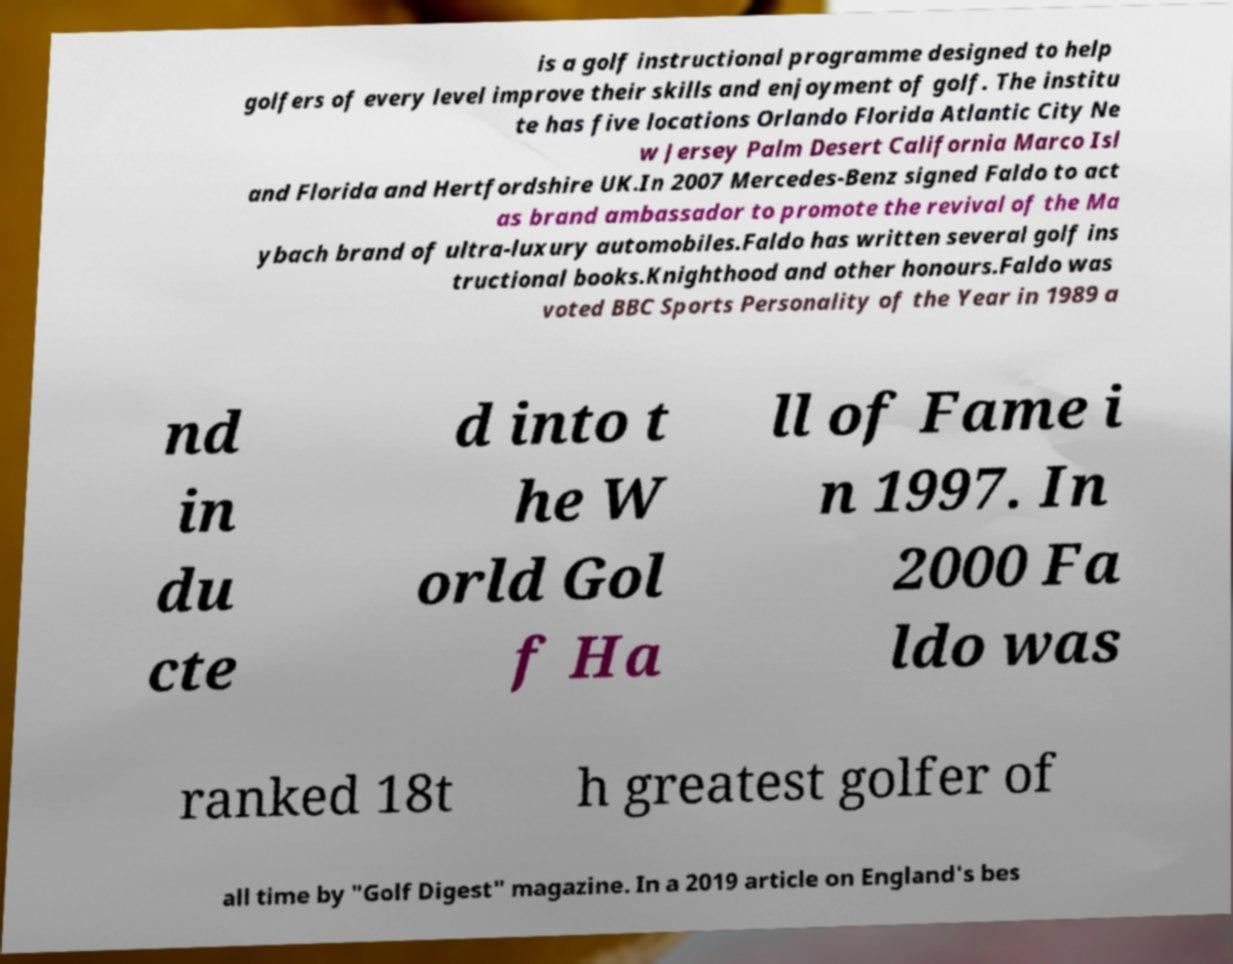Can you accurately transcribe the text from the provided image for me? is a golf instructional programme designed to help golfers of every level improve their skills and enjoyment of golf. The institu te has five locations Orlando Florida Atlantic City Ne w Jersey Palm Desert California Marco Isl and Florida and Hertfordshire UK.In 2007 Mercedes-Benz signed Faldo to act as brand ambassador to promote the revival of the Ma ybach brand of ultra-luxury automobiles.Faldo has written several golf ins tructional books.Knighthood and other honours.Faldo was voted BBC Sports Personality of the Year in 1989 a nd in du cte d into t he W orld Gol f Ha ll of Fame i n 1997. In 2000 Fa ldo was ranked 18t h greatest golfer of all time by "Golf Digest" magazine. In a 2019 article on England's bes 